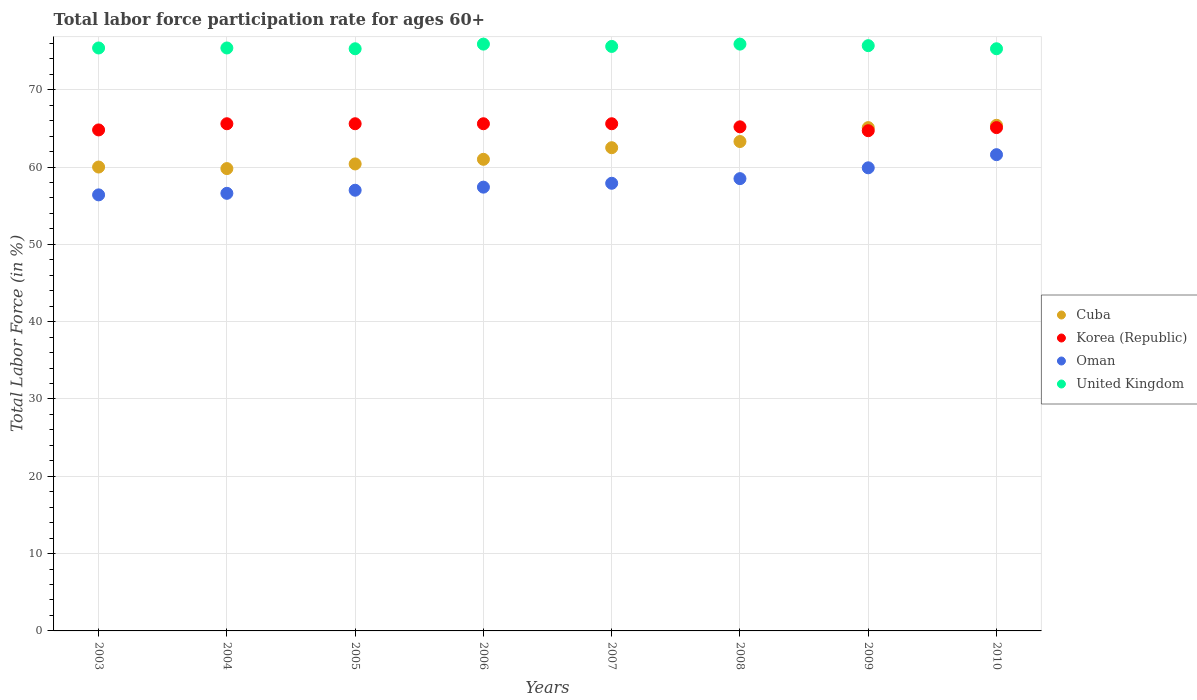Across all years, what is the maximum labor force participation rate in Korea (Republic)?
Make the answer very short. 65.6. Across all years, what is the minimum labor force participation rate in United Kingdom?
Your response must be concise. 75.3. In which year was the labor force participation rate in Oman maximum?
Provide a succinct answer. 2010. In which year was the labor force participation rate in Korea (Republic) minimum?
Ensure brevity in your answer.  2009. What is the total labor force participation rate in Korea (Republic) in the graph?
Your answer should be compact. 522.2. What is the difference between the labor force participation rate in Oman in 2006 and that in 2010?
Give a very brief answer. -4.2. What is the difference between the labor force participation rate in United Kingdom in 2006 and the labor force participation rate in Oman in 2009?
Give a very brief answer. 16. What is the average labor force participation rate in Oman per year?
Offer a very short reply. 58.16. In the year 2005, what is the difference between the labor force participation rate in Oman and labor force participation rate in Korea (Republic)?
Offer a very short reply. -8.6. What is the ratio of the labor force participation rate in Oman in 2003 to that in 2008?
Offer a terse response. 0.96. Is the labor force participation rate in United Kingdom in 2003 less than that in 2010?
Ensure brevity in your answer.  No. What is the difference between the highest and the second highest labor force participation rate in Cuba?
Your answer should be very brief. 0.3. What is the difference between the highest and the lowest labor force participation rate in Oman?
Your answer should be very brief. 5.2. In how many years, is the labor force participation rate in Korea (Republic) greater than the average labor force participation rate in Korea (Republic) taken over all years?
Give a very brief answer. 4. Is the sum of the labor force participation rate in United Kingdom in 2007 and 2009 greater than the maximum labor force participation rate in Cuba across all years?
Provide a succinct answer. Yes. Is the labor force participation rate in United Kingdom strictly less than the labor force participation rate in Oman over the years?
Your answer should be very brief. No. What is the difference between two consecutive major ticks on the Y-axis?
Your response must be concise. 10. Are the values on the major ticks of Y-axis written in scientific E-notation?
Give a very brief answer. No. Does the graph contain any zero values?
Your answer should be compact. No. Does the graph contain grids?
Provide a succinct answer. Yes. How many legend labels are there?
Your answer should be very brief. 4. How are the legend labels stacked?
Provide a succinct answer. Vertical. What is the title of the graph?
Your answer should be very brief. Total labor force participation rate for ages 60+. What is the label or title of the X-axis?
Provide a succinct answer. Years. What is the label or title of the Y-axis?
Offer a terse response. Total Labor Force (in %). What is the Total Labor Force (in %) in Korea (Republic) in 2003?
Offer a very short reply. 64.8. What is the Total Labor Force (in %) in Oman in 2003?
Give a very brief answer. 56.4. What is the Total Labor Force (in %) in United Kingdom in 2003?
Ensure brevity in your answer.  75.4. What is the Total Labor Force (in %) of Cuba in 2004?
Make the answer very short. 59.8. What is the Total Labor Force (in %) of Korea (Republic) in 2004?
Offer a terse response. 65.6. What is the Total Labor Force (in %) in Oman in 2004?
Make the answer very short. 56.6. What is the Total Labor Force (in %) of United Kingdom in 2004?
Give a very brief answer. 75.4. What is the Total Labor Force (in %) of Cuba in 2005?
Your answer should be very brief. 60.4. What is the Total Labor Force (in %) of Korea (Republic) in 2005?
Your answer should be compact. 65.6. What is the Total Labor Force (in %) of United Kingdom in 2005?
Offer a terse response. 75.3. What is the Total Labor Force (in %) of Cuba in 2006?
Provide a succinct answer. 61. What is the Total Labor Force (in %) of Korea (Republic) in 2006?
Provide a short and direct response. 65.6. What is the Total Labor Force (in %) of Oman in 2006?
Ensure brevity in your answer.  57.4. What is the Total Labor Force (in %) in United Kingdom in 2006?
Provide a short and direct response. 75.9. What is the Total Labor Force (in %) in Cuba in 2007?
Provide a succinct answer. 62.5. What is the Total Labor Force (in %) of Korea (Republic) in 2007?
Your answer should be very brief. 65.6. What is the Total Labor Force (in %) of Oman in 2007?
Your response must be concise. 57.9. What is the Total Labor Force (in %) of United Kingdom in 2007?
Offer a very short reply. 75.6. What is the Total Labor Force (in %) of Cuba in 2008?
Offer a terse response. 63.3. What is the Total Labor Force (in %) of Korea (Republic) in 2008?
Make the answer very short. 65.2. What is the Total Labor Force (in %) in Oman in 2008?
Provide a succinct answer. 58.5. What is the Total Labor Force (in %) of United Kingdom in 2008?
Your answer should be compact. 75.9. What is the Total Labor Force (in %) of Cuba in 2009?
Provide a short and direct response. 65.1. What is the Total Labor Force (in %) in Korea (Republic) in 2009?
Offer a terse response. 64.7. What is the Total Labor Force (in %) in Oman in 2009?
Your answer should be compact. 59.9. What is the Total Labor Force (in %) in United Kingdom in 2009?
Your answer should be very brief. 75.7. What is the Total Labor Force (in %) in Cuba in 2010?
Offer a very short reply. 65.4. What is the Total Labor Force (in %) in Korea (Republic) in 2010?
Make the answer very short. 65.1. What is the Total Labor Force (in %) of Oman in 2010?
Make the answer very short. 61.6. What is the Total Labor Force (in %) of United Kingdom in 2010?
Provide a succinct answer. 75.3. Across all years, what is the maximum Total Labor Force (in %) in Cuba?
Give a very brief answer. 65.4. Across all years, what is the maximum Total Labor Force (in %) of Korea (Republic)?
Your answer should be compact. 65.6. Across all years, what is the maximum Total Labor Force (in %) of Oman?
Your answer should be very brief. 61.6. Across all years, what is the maximum Total Labor Force (in %) of United Kingdom?
Give a very brief answer. 75.9. Across all years, what is the minimum Total Labor Force (in %) in Cuba?
Make the answer very short. 59.8. Across all years, what is the minimum Total Labor Force (in %) of Korea (Republic)?
Offer a terse response. 64.7. Across all years, what is the minimum Total Labor Force (in %) of Oman?
Your answer should be compact. 56.4. Across all years, what is the minimum Total Labor Force (in %) in United Kingdom?
Offer a very short reply. 75.3. What is the total Total Labor Force (in %) in Cuba in the graph?
Offer a very short reply. 497.5. What is the total Total Labor Force (in %) of Korea (Republic) in the graph?
Provide a short and direct response. 522.2. What is the total Total Labor Force (in %) in Oman in the graph?
Your answer should be very brief. 465.3. What is the total Total Labor Force (in %) of United Kingdom in the graph?
Give a very brief answer. 604.5. What is the difference between the Total Labor Force (in %) of Korea (Republic) in 2003 and that in 2004?
Provide a succinct answer. -0.8. What is the difference between the Total Labor Force (in %) of Oman in 2003 and that in 2004?
Keep it short and to the point. -0.2. What is the difference between the Total Labor Force (in %) of United Kingdom in 2003 and that in 2004?
Offer a very short reply. 0. What is the difference between the Total Labor Force (in %) in United Kingdom in 2003 and that in 2005?
Ensure brevity in your answer.  0.1. What is the difference between the Total Labor Force (in %) of Cuba in 2003 and that in 2006?
Give a very brief answer. -1. What is the difference between the Total Labor Force (in %) in Cuba in 2003 and that in 2008?
Ensure brevity in your answer.  -3.3. What is the difference between the Total Labor Force (in %) of Korea (Republic) in 2003 and that in 2008?
Provide a short and direct response. -0.4. What is the difference between the Total Labor Force (in %) in Cuba in 2003 and that in 2009?
Give a very brief answer. -5.1. What is the difference between the Total Labor Force (in %) in Oman in 2003 and that in 2009?
Ensure brevity in your answer.  -3.5. What is the difference between the Total Labor Force (in %) of Cuba in 2003 and that in 2010?
Your response must be concise. -5.4. What is the difference between the Total Labor Force (in %) in Korea (Republic) in 2003 and that in 2010?
Offer a very short reply. -0.3. What is the difference between the Total Labor Force (in %) in Oman in 2003 and that in 2010?
Ensure brevity in your answer.  -5.2. What is the difference between the Total Labor Force (in %) in Korea (Republic) in 2004 and that in 2005?
Make the answer very short. 0. What is the difference between the Total Labor Force (in %) of United Kingdom in 2004 and that in 2005?
Give a very brief answer. 0.1. What is the difference between the Total Labor Force (in %) in Cuba in 2004 and that in 2006?
Your response must be concise. -1.2. What is the difference between the Total Labor Force (in %) of Korea (Republic) in 2004 and that in 2006?
Provide a short and direct response. 0. What is the difference between the Total Labor Force (in %) of Oman in 2004 and that in 2006?
Offer a very short reply. -0.8. What is the difference between the Total Labor Force (in %) of Oman in 2004 and that in 2007?
Offer a very short reply. -1.3. What is the difference between the Total Labor Force (in %) of United Kingdom in 2004 and that in 2007?
Give a very brief answer. -0.2. What is the difference between the Total Labor Force (in %) of Cuba in 2004 and that in 2008?
Your answer should be very brief. -3.5. What is the difference between the Total Labor Force (in %) in United Kingdom in 2004 and that in 2008?
Keep it short and to the point. -0.5. What is the difference between the Total Labor Force (in %) in Korea (Republic) in 2004 and that in 2009?
Your answer should be very brief. 0.9. What is the difference between the Total Labor Force (in %) of Oman in 2004 and that in 2009?
Your answer should be very brief. -3.3. What is the difference between the Total Labor Force (in %) in United Kingdom in 2004 and that in 2009?
Give a very brief answer. -0.3. What is the difference between the Total Labor Force (in %) of Cuba in 2004 and that in 2010?
Give a very brief answer. -5.6. What is the difference between the Total Labor Force (in %) of Oman in 2005 and that in 2006?
Ensure brevity in your answer.  -0.4. What is the difference between the Total Labor Force (in %) of United Kingdom in 2005 and that in 2007?
Make the answer very short. -0.3. What is the difference between the Total Labor Force (in %) of Cuba in 2005 and that in 2008?
Ensure brevity in your answer.  -2.9. What is the difference between the Total Labor Force (in %) in Oman in 2005 and that in 2008?
Provide a short and direct response. -1.5. What is the difference between the Total Labor Force (in %) of Cuba in 2005 and that in 2009?
Make the answer very short. -4.7. What is the difference between the Total Labor Force (in %) of Oman in 2005 and that in 2009?
Offer a terse response. -2.9. What is the difference between the Total Labor Force (in %) of United Kingdom in 2005 and that in 2009?
Provide a short and direct response. -0.4. What is the difference between the Total Labor Force (in %) of Cuba in 2005 and that in 2010?
Your answer should be compact. -5. What is the difference between the Total Labor Force (in %) in Oman in 2005 and that in 2010?
Your answer should be very brief. -4.6. What is the difference between the Total Labor Force (in %) in Cuba in 2006 and that in 2007?
Your response must be concise. -1.5. What is the difference between the Total Labor Force (in %) of Korea (Republic) in 2006 and that in 2007?
Make the answer very short. 0. What is the difference between the Total Labor Force (in %) in Oman in 2006 and that in 2007?
Your answer should be very brief. -0.5. What is the difference between the Total Labor Force (in %) in Cuba in 2006 and that in 2008?
Your response must be concise. -2.3. What is the difference between the Total Labor Force (in %) in Korea (Republic) in 2006 and that in 2008?
Provide a succinct answer. 0.4. What is the difference between the Total Labor Force (in %) in Cuba in 2006 and that in 2009?
Make the answer very short. -4.1. What is the difference between the Total Labor Force (in %) of Korea (Republic) in 2006 and that in 2009?
Give a very brief answer. 0.9. What is the difference between the Total Labor Force (in %) of Cuba in 2007 and that in 2008?
Provide a succinct answer. -0.8. What is the difference between the Total Labor Force (in %) of United Kingdom in 2007 and that in 2008?
Give a very brief answer. -0.3. What is the difference between the Total Labor Force (in %) of Oman in 2007 and that in 2009?
Keep it short and to the point. -2. What is the difference between the Total Labor Force (in %) in United Kingdom in 2007 and that in 2009?
Ensure brevity in your answer.  -0.1. What is the difference between the Total Labor Force (in %) of Cuba in 2007 and that in 2010?
Keep it short and to the point. -2.9. What is the difference between the Total Labor Force (in %) in Korea (Republic) in 2007 and that in 2010?
Offer a very short reply. 0.5. What is the difference between the Total Labor Force (in %) of Oman in 2007 and that in 2010?
Ensure brevity in your answer.  -3.7. What is the difference between the Total Labor Force (in %) of United Kingdom in 2008 and that in 2009?
Keep it short and to the point. 0.2. What is the difference between the Total Labor Force (in %) in Korea (Republic) in 2008 and that in 2010?
Your answer should be very brief. 0.1. What is the difference between the Total Labor Force (in %) in Oman in 2008 and that in 2010?
Provide a short and direct response. -3.1. What is the difference between the Total Labor Force (in %) in Cuba in 2009 and that in 2010?
Your answer should be compact. -0.3. What is the difference between the Total Labor Force (in %) in Oman in 2009 and that in 2010?
Your answer should be very brief. -1.7. What is the difference between the Total Labor Force (in %) in Cuba in 2003 and the Total Labor Force (in %) in United Kingdom in 2004?
Your answer should be compact. -15.4. What is the difference between the Total Labor Force (in %) of Oman in 2003 and the Total Labor Force (in %) of United Kingdom in 2004?
Your response must be concise. -19. What is the difference between the Total Labor Force (in %) of Cuba in 2003 and the Total Labor Force (in %) of Oman in 2005?
Ensure brevity in your answer.  3. What is the difference between the Total Labor Force (in %) in Cuba in 2003 and the Total Labor Force (in %) in United Kingdom in 2005?
Your answer should be very brief. -15.3. What is the difference between the Total Labor Force (in %) in Oman in 2003 and the Total Labor Force (in %) in United Kingdom in 2005?
Give a very brief answer. -18.9. What is the difference between the Total Labor Force (in %) in Cuba in 2003 and the Total Labor Force (in %) in Korea (Republic) in 2006?
Give a very brief answer. -5.6. What is the difference between the Total Labor Force (in %) in Cuba in 2003 and the Total Labor Force (in %) in Oman in 2006?
Your answer should be very brief. 2.6. What is the difference between the Total Labor Force (in %) of Cuba in 2003 and the Total Labor Force (in %) of United Kingdom in 2006?
Provide a succinct answer. -15.9. What is the difference between the Total Labor Force (in %) in Korea (Republic) in 2003 and the Total Labor Force (in %) in United Kingdom in 2006?
Make the answer very short. -11.1. What is the difference between the Total Labor Force (in %) in Oman in 2003 and the Total Labor Force (in %) in United Kingdom in 2006?
Your response must be concise. -19.5. What is the difference between the Total Labor Force (in %) in Cuba in 2003 and the Total Labor Force (in %) in Korea (Republic) in 2007?
Offer a terse response. -5.6. What is the difference between the Total Labor Force (in %) in Cuba in 2003 and the Total Labor Force (in %) in United Kingdom in 2007?
Provide a short and direct response. -15.6. What is the difference between the Total Labor Force (in %) of Korea (Republic) in 2003 and the Total Labor Force (in %) of Oman in 2007?
Your answer should be compact. 6.9. What is the difference between the Total Labor Force (in %) in Oman in 2003 and the Total Labor Force (in %) in United Kingdom in 2007?
Offer a terse response. -19.2. What is the difference between the Total Labor Force (in %) in Cuba in 2003 and the Total Labor Force (in %) in Korea (Republic) in 2008?
Your response must be concise. -5.2. What is the difference between the Total Labor Force (in %) in Cuba in 2003 and the Total Labor Force (in %) in Oman in 2008?
Provide a short and direct response. 1.5. What is the difference between the Total Labor Force (in %) in Cuba in 2003 and the Total Labor Force (in %) in United Kingdom in 2008?
Make the answer very short. -15.9. What is the difference between the Total Labor Force (in %) in Korea (Republic) in 2003 and the Total Labor Force (in %) in Oman in 2008?
Offer a terse response. 6.3. What is the difference between the Total Labor Force (in %) of Oman in 2003 and the Total Labor Force (in %) of United Kingdom in 2008?
Offer a very short reply. -19.5. What is the difference between the Total Labor Force (in %) in Cuba in 2003 and the Total Labor Force (in %) in Oman in 2009?
Ensure brevity in your answer.  0.1. What is the difference between the Total Labor Force (in %) in Cuba in 2003 and the Total Labor Force (in %) in United Kingdom in 2009?
Offer a very short reply. -15.7. What is the difference between the Total Labor Force (in %) in Korea (Republic) in 2003 and the Total Labor Force (in %) in Oman in 2009?
Your answer should be compact. 4.9. What is the difference between the Total Labor Force (in %) in Korea (Republic) in 2003 and the Total Labor Force (in %) in United Kingdom in 2009?
Give a very brief answer. -10.9. What is the difference between the Total Labor Force (in %) of Oman in 2003 and the Total Labor Force (in %) of United Kingdom in 2009?
Make the answer very short. -19.3. What is the difference between the Total Labor Force (in %) in Cuba in 2003 and the Total Labor Force (in %) in United Kingdom in 2010?
Offer a terse response. -15.3. What is the difference between the Total Labor Force (in %) of Korea (Republic) in 2003 and the Total Labor Force (in %) of Oman in 2010?
Your response must be concise. 3.2. What is the difference between the Total Labor Force (in %) of Korea (Republic) in 2003 and the Total Labor Force (in %) of United Kingdom in 2010?
Offer a terse response. -10.5. What is the difference between the Total Labor Force (in %) of Oman in 2003 and the Total Labor Force (in %) of United Kingdom in 2010?
Give a very brief answer. -18.9. What is the difference between the Total Labor Force (in %) of Cuba in 2004 and the Total Labor Force (in %) of Korea (Republic) in 2005?
Ensure brevity in your answer.  -5.8. What is the difference between the Total Labor Force (in %) of Cuba in 2004 and the Total Labor Force (in %) of Oman in 2005?
Make the answer very short. 2.8. What is the difference between the Total Labor Force (in %) in Cuba in 2004 and the Total Labor Force (in %) in United Kingdom in 2005?
Provide a succinct answer. -15.5. What is the difference between the Total Labor Force (in %) in Korea (Republic) in 2004 and the Total Labor Force (in %) in Oman in 2005?
Make the answer very short. 8.6. What is the difference between the Total Labor Force (in %) in Oman in 2004 and the Total Labor Force (in %) in United Kingdom in 2005?
Keep it short and to the point. -18.7. What is the difference between the Total Labor Force (in %) in Cuba in 2004 and the Total Labor Force (in %) in United Kingdom in 2006?
Make the answer very short. -16.1. What is the difference between the Total Labor Force (in %) in Oman in 2004 and the Total Labor Force (in %) in United Kingdom in 2006?
Your answer should be compact. -19.3. What is the difference between the Total Labor Force (in %) in Cuba in 2004 and the Total Labor Force (in %) in Korea (Republic) in 2007?
Give a very brief answer. -5.8. What is the difference between the Total Labor Force (in %) in Cuba in 2004 and the Total Labor Force (in %) in Oman in 2007?
Your answer should be very brief. 1.9. What is the difference between the Total Labor Force (in %) in Cuba in 2004 and the Total Labor Force (in %) in United Kingdom in 2007?
Your answer should be very brief. -15.8. What is the difference between the Total Labor Force (in %) in Cuba in 2004 and the Total Labor Force (in %) in Oman in 2008?
Ensure brevity in your answer.  1.3. What is the difference between the Total Labor Force (in %) of Cuba in 2004 and the Total Labor Force (in %) of United Kingdom in 2008?
Give a very brief answer. -16.1. What is the difference between the Total Labor Force (in %) of Korea (Republic) in 2004 and the Total Labor Force (in %) of Oman in 2008?
Offer a very short reply. 7.1. What is the difference between the Total Labor Force (in %) of Oman in 2004 and the Total Labor Force (in %) of United Kingdom in 2008?
Your answer should be compact. -19.3. What is the difference between the Total Labor Force (in %) of Cuba in 2004 and the Total Labor Force (in %) of Korea (Republic) in 2009?
Keep it short and to the point. -4.9. What is the difference between the Total Labor Force (in %) in Cuba in 2004 and the Total Labor Force (in %) in United Kingdom in 2009?
Make the answer very short. -15.9. What is the difference between the Total Labor Force (in %) of Korea (Republic) in 2004 and the Total Labor Force (in %) of Oman in 2009?
Your answer should be compact. 5.7. What is the difference between the Total Labor Force (in %) in Korea (Republic) in 2004 and the Total Labor Force (in %) in United Kingdom in 2009?
Keep it short and to the point. -10.1. What is the difference between the Total Labor Force (in %) of Oman in 2004 and the Total Labor Force (in %) of United Kingdom in 2009?
Ensure brevity in your answer.  -19.1. What is the difference between the Total Labor Force (in %) in Cuba in 2004 and the Total Labor Force (in %) in Korea (Republic) in 2010?
Keep it short and to the point. -5.3. What is the difference between the Total Labor Force (in %) in Cuba in 2004 and the Total Labor Force (in %) in Oman in 2010?
Give a very brief answer. -1.8. What is the difference between the Total Labor Force (in %) in Cuba in 2004 and the Total Labor Force (in %) in United Kingdom in 2010?
Provide a succinct answer. -15.5. What is the difference between the Total Labor Force (in %) in Korea (Republic) in 2004 and the Total Labor Force (in %) in Oman in 2010?
Ensure brevity in your answer.  4. What is the difference between the Total Labor Force (in %) of Oman in 2004 and the Total Labor Force (in %) of United Kingdom in 2010?
Keep it short and to the point. -18.7. What is the difference between the Total Labor Force (in %) of Cuba in 2005 and the Total Labor Force (in %) of United Kingdom in 2006?
Ensure brevity in your answer.  -15.5. What is the difference between the Total Labor Force (in %) in Korea (Republic) in 2005 and the Total Labor Force (in %) in United Kingdom in 2006?
Keep it short and to the point. -10.3. What is the difference between the Total Labor Force (in %) of Oman in 2005 and the Total Labor Force (in %) of United Kingdom in 2006?
Your response must be concise. -18.9. What is the difference between the Total Labor Force (in %) in Cuba in 2005 and the Total Labor Force (in %) in Oman in 2007?
Keep it short and to the point. 2.5. What is the difference between the Total Labor Force (in %) in Cuba in 2005 and the Total Labor Force (in %) in United Kingdom in 2007?
Make the answer very short. -15.2. What is the difference between the Total Labor Force (in %) of Korea (Republic) in 2005 and the Total Labor Force (in %) of United Kingdom in 2007?
Your response must be concise. -10. What is the difference between the Total Labor Force (in %) of Oman in 2005 and the Total Labor Force (in %) of United Kingdom in 2007?
Offer a very short reply. -18.6. What is the difference between the Total Labor Force (in %) in Cuba in 2005 and the Total Labor Force (in %) in Korea (Republic) in 2008?
Keep it short and to the point. -4.8. What is the difference between the Total Labor Force (in %) of Cuba in 2005 and the Total Labor Force (in %) of United Kingdom in 2008?
Offer a terse response. -15.5. What is the difference between the Total Labor Force (in %) of Korea (Republic) in 2005 and the Total Labor Force (in %) of Oman in 2008?
Provide a succinct answer. 7.1. What is the difference between the Total Labor Force (in %) in Oman in 2005 and the Total Labor Force (in %) in United Kingdom in 2008?
Your response must be concise. -18.9. What is the difference between the Total Labor Force (in %) of Cuba in 2005 and the Total Labor Force (in %) of Oman in 2009?
Ensure brevity in your answer.  0.5. What is the difference between the Total Labor Force (in %) in Cuba in 2005 and the Total Labor Force (in %) in United Kingdom in 2009?
Your response must be concise. -15.3. What is the difference between the Total Labor Force (in %) of Korea (Republic) in 2005 and the Total Labor Force (in %) of Oman in 2009?
Provide a succinct answer. 5.7. What is the difference between the Total Labor Force (in %) of Oman in 2005 and the Total Labor Force (in %) of United Kingdom in 2009?
Offer a terse response. -18.7. What is the difference between the Total Labor Force (in %) in Cuba in 2005 and the Total Labor Force (in %) in Oman in 2010?
Offer a terse response. -1.2. What is the difference between the Total Labor Force (in %) in Cuba in 2005 and the Total Labor Force (in %) in United Kingdom in 2010?
Offer a very short reply. -14.9. What is the difference between the Total Labor Force (in %) of Korea (Republic) in 2005 and the Total Labor Force (in %) of United Kingdom in 2010?
Provide a succinct answer. -9.7. What is the difference between the Total Labor Force (in %) of Oman in 2005 and the Total Labor Force (in %) of United Kingdom in 2010?
Ensure brevity in your answer.  -18.3. What is the difference between the Total Labor Force (in %) of Cuba in 2006 and the Total Labor Force (in %) of United Kingdom in 2007?
Give a very brief answer. -14.6. What is the difference between the Total Labor Force (in %) of Korea (Republic) in 2006 and the Total Labor Force (in %) of Oman in 2007?
Keep it short and to the point. 7.7. What is the difference between the Total Labor Force (in %) in Korea (Republic) in 2006 and the Total Labor Force (in %) in United Kingdom in 2007?
Give a very brief answer. -10. What is the difference between the Total Labor Force (in %) of Oman in 2006 and the Total Labor Force (in %) of United Kingdom in 2007?
Your answer should be very brief. -18.2. What is the difference between the Total Labor Force (in %) of Cuba in 2006 and the Total Labor Force (in %) of United Kingdom in 2008?
Your answer should be very brief. -14.9. What is the difference between the Total Labor Force (in %) in Oman in 2006 and the Total Labor Force (in %) in United Kingdom in 2008?
Offer a terse response. -18.5. What is the difference between the Total Labor Force (in %) of Cuba in 2006 and the Total Labor Force (in %) of Korea (Republic) in 2009?
Your response must be concise. -3.7. What is the difference between the Total Labor Force (in %) of Cuba in 2006 and the Total Labor Force (in %) of United Kingdom in 2009?
Ensure brevity in your answer.  -14.7. What is the difference between the Total Labor Force (in %) in Korea (Republic) in 2006 and the Total Labor Force (in %) in Oman in 2009?
Ensure brevity in your answer.  5.7. What is the difference between the Total Labor Force (in %) of Oman in 2006 and the Total Labor Force (in %) of United Kingdom in 2009?
Ensure brevity in your answer.  -18.3. What is the difference between the Total Labor Force (in %) of Cuba in 2006 and the Total Labor Force (in %) of Korea (Republic) in 2010?
Offer a very short reply. -4.1. What is the difference between the Total Labor Force (in %) in Cuba in 2006 and the Total Labor Force (in %) in United Kingdom in 2010?
Provide a succinct answer. -14.3. What is the difference between the Total Labor Force (in %) in Oman in 2006 and the Total Labor Force (in %) in United Kingdom in 2010?
Offer a terse response. -17.9. What is the difference between the Total Labor Force (in %) of Cuba in 2007 and the Total Labor Force (in %) of Oman in 2008?
Give a very brief answer. 4. What is the difference between the Total Labor Force (in %) of Cuba in 2007 and the Total Labor Force (in %) of United Kingdom in 2008?
Give a very brief answer. -13.4. What is the difference between the Total Labor Force (in %) of Korea (Republic) in 2007 and the Total Labor Force (in %) of United Kingdom in 2008?
Provide a short and direct response. -10.3. What is the difference between the Total Labor Force (in %) of Cuba in 2007 and the Total Labor Force (in %) of United Kingdom in 2009?
Provide a succinct answer. -13.2. What is the difference between the Total Labor Force (in %) of Korea (Republic) in 2007 and the Total Labor Force (in %) of United Kingdom in 2009?
Make the answer very short. -10.1. What is the difference between the Total Labor Force (in %) of Oman in 2007 and the Total Labor Force (in %) of United Kingdom in 2009?
Give a very brief answer. -17.8. What is the difference between the Total Labor Force (in %) in Cuba in 2007 and the Total Labor Force (in %) in Korea (Republic) in 2010?
Your answer should be compact. -2.6. What is the difference between the Total Labor Force (in %) in Cuba in 2007 and the Total Labor Force (in %) in United Kingdom in 2010?
Make the answer very short. -12.8. What is the difference between the Total Labor Force (in %) of Korea (Republic) in 2007 and the Total Labor Force (in %) of United Kingdom in 2010?
Offer a terse response. -9.7. What is the difference between the Total Labor Force (in %) of Oman in 2007 and the Total Labor Force (in %) of United Kingdom in 2010?
Provide a short and direct response. -17.4. What is the difference between the Total Labor Force (in %) in Cuba in 2008 and the Total Labor Force (in %) in Oman in 2009?
Ensure brevity in your answer.  3.4. What is the difference between the Total Labor Force (in %) of Oman in 2008 and the Total Labor Force (in %) of United Kingdom in 2009?
Provide a short and direct response. -17.2. What is the difference between the Total Labor Force (in %) of Oman in 2008 and the Total Labor Force (in %) of United Kingdom in 2010?
Make the answer very short. -16.8. What is the difference between the Total Labor Force (in %) of Cuba in 2009 and the Total Labor Force (in %) of Korea (Republic) in 2010?
Make the answer very short. 0. What is the difference between the Total Labor Force (in %) in Oman in 2009 and the Total Labor Force (in %) in United Kingdom in 2010?
Keep it short and to the point. -15.4. What is the average Total Labor Force (in %) of Cuba per year?
Provide a succinct answer. 62.19. What is the average Total Labor Force (in %) of Korea (Republic) per year?
Offer a very short reply. 65.28. What is the average Total Labor Force (in %) in Oman per year?
Provide a short and direct response. 58.16. What is the average Total Labor Force (in %) in United Kingdom per year?
Make the answer very short. 75.56. In the year 2003, what is the difference between the Total Labor Force (in %) of Cuba and Total Labor Force (in %) of Oman?
Make the answer very short. 3.6. In the year 2003, what is the difference between the Total Labor Force (in %) in Cuba and Total Labor Force (in %) in United Kingdom?
Offer a terse response. -15.4. In the year 2003, what is the difference between the Total Labor Force (in %) in Korea (Republic) and Total Labor Force (in %) in Oman?
Make the answer very short. 8.4. In the year 2003, what is the difference between the Total Labor Force (in %) of Oman and Total Labor Force (in %) of United Kingdom?
Make the answer very short. -19. In the year 2004, what is the difference between the Total Labor Force (in %) of Cuba and Total Labor Force (in %) of Korea (Republic)?
Make the answer very short. -5.8. In the year 2004, what is the difference between the Total Labor Force (in %) of Cuba and Total Labor Force (in %) of United Kingdom?
Your response must be concise. -15.6. In the year 2004, what is the difference between the Total Labor Force (in %) of Korea (Republic) and Total Labor Force (in %) of Oman?
Offer a very short reply. 9. In the year 2004, what is the difference between the Total Labor Force (in %) of Oman and Total Labor Force (in %) of United Kingdom?
Provide a succinct answer. -18.8. In the year 2005, what is the difference between the Total Labor Force (in %) of Cuba and Total Labor Force (in %) of Korea (Republic)?
Your answer should be very brief. -5.2. In the year 2005, what is the difference between the Total Labor Force (in %) in Cuba and Total Labor Force (in %) in United Kingdom?
Offer a terse response. -14.9. In the year 2005, what is the difference between the Total Labor Force (in %) of Korea (Republic) and Total Labor Force (in %) of United Kingdom?
Your answer should be compact. -9.7. In the year 2005, what is the difference between the Total Labor Force (in %) of Oman and Total Labor Force (in %) of United Kingdom?
Keep it short and to the point. -18.3. In the year 2006, what is the difference between the Total Labor Force (in %) in Cuba and Total Labor Force (in %) in Korea (Republic)?
Provide a short and direct response. -4.6. In the year 2006, what is the difference between the Total Labor Force (in %) in Cuba and Total Labor Force (in %) in Oman?
Your answer should be very brief. 3.6. In the year 2006, what is the difference between the Total Labor Force (in %) in Cuba and Total Labor Force (in %) in United Kingdom?
Keep it short and to the point. -14.9. In the year 2006, what is the difference between the Total Labor Force (in %) of Oman and Total Labor Force (in %) of United Kingdom?
Give a very brief answer. -18.5. In the year 2007, what is the difference between the Total Labor Force (in %) of Cuba and Total Labor Force (in %) of Oman?
Provide a short and direct response. 4.6. In the year 2007, what is the difference between the Total Labor Force (in %) of Cuba and Total Labor Force (in %) of United Kingdom?
Your response must be concise. -13.1. In the year 2007, what is the difference between the Total Labor Force (in %) of Oman and Total Labor Force (in %) of United Kingdom?
Make the answer very short. -17.7. In the year 2008, what is the difference between the Total Labor Force (in %) of Cuba and Total Labor Force (in %) of Korea (Republic)?
Offer a very short reply. -1.9. In the year 2008, what is the difference between the Total Labor Force (in %) in Cuba and Total Labor Force (in %) in Oman?
Make the answer very short. 4.8. In the year 2008, what is the difference between the Total Labor Force (in %) of Cuba and Total Labor Force (in %) of United Kingdom?
Your answer should be compact. -12.6. In the year 2008, what is the difference between the Total Labor Force (in %) in Korea (Republic) and Total Labor Force (in %) in United Kingdom?
Offer a very short reply. -10.7. In the year 2008, what is the difference between the Total Labor Force (in %) in Oman and Total Labor Force (in %) in United Kingdom?
Your answer should be compact. -17.4. In the year 2009, what is the difference between the Total Labor Force (in %) of Cuba and Total Labor Force (in %) of Korea (Republic)?
Your response must be concise. 0.4. In the year 2009, what is the difference between the Total Labor Force (in %) in Cuba and Total Labor Force (in %) in Oman?
Your answer should be compact. 5.2. In the year 2009, what is the difference between the Total Labor Force (in %) of Cuba and Total Labor Force (in %) of United Kingdom?
Give a very brief answer. -10.6. In the year 2009, what is the difference between the Total Labor Force (in %) of Korea (Republic) and Total Labor Force (in %) of Oman?
Give a very brief answer. 4.8. In the year 2009, what is the difference between the Total Labor Force (in %) in Oman and Total Labor Force (in %) in United Kingdom?
Offer a very short reply. -15.8. In the year 2010, what is the difference between the Total Labor Force (in %) in Cuba and Total Labor Force (in %) in Korea (Republic)?
Make the answer very short. 0.3. In the year 2010, what is the difference between the Total Labor Force (in %) in Cuba and Total Labor Force (in %) in Oman?
Provide a succinct answer. 3.8. In the year 2010, what is the difference between the Total Labor Force (in %) in Cuba and Total Labor Force (in %) in United Kingdom?
Provide a short and direct response. -9.9. In the year 2010, what is the difference between the Total Labor Force (in %) of Oman and Total Labor Force (in %) of United Kingdom?
Give a very brief answer. -13.7. What is the ratio of the Total Labor Force (in %) of Cuba in 2003 to that in 2004?
Your answer should be compact. 1. What is the ratio of the Total Labor Force (in %) of Oman in 2003 to that in 2004?
Provide a succinct answer. 1. What is the ratio of the Total Labor Force (in %) of Cuba in 2003 to that in 2005?
Ensure brevity in your answer.  0.99. What is the ratio of the Total Labor Force (in %) of United Kingdom in 2003 to that in 2005?
Ensure brevity in your answer.  1. What is the ratio of the Total Labor Force (in %) of Cuba in 2003 to that in 2006?
Your answer should be very brief. 0.98. What is the ratio of the Total Labor Force (in %) of Korea (Republic) in 2003 to that in 2006?
Ensure brevity in your answer.  0.99. What is the ratio of the Total Labor Force (in %) in Oman in 2003 to that in 2006?
Provide a short and direct response. 0.98. What is the ratio of the Total Labor Force (in %) in Oman in 2003 to that in 2007?
Your answer should be very brief. 0.97. What is the ratio of the Total Labor Force (in %) of United Kingdom in 2003 to that in 2007?
Your response must be concise. 1. What is the ratio of the Total Labor Force (in %) of Cuba in 2003 to that in 2008?
Your response must be concise. 0.95. What is the ratio of the Total Labor Force (in %) of Korea (Republic) in 2003 to that in 2008?
Provide a succinct answer. 0.99. What is the ratio of the Total Labor Force (in %) in Oman in 2003 to that in 2008?
Your answer should be very brief. 0.96. What is the ratio of the Total Labor Force (in %) in United Kingdom in 2003 to that in 2008?
Your answer should be very brief. 0.99. What is the ratio of the Total Labor Force (in %) in Cuba in 2003 to that in 2009?
Your response must be concise. 0.92. What is the ratio of the Total Labor Force (in %) in Korea (Republic) in 2003 to that in 2009?
Offer a very short reply. 1. What is the ratio of the Total Labor Force (in %) of Oman in 2003 to that in 2009?
Your answer should be compact. 0.94. What is the ratio of the Total Labor Force (in %) of Cuba in 2003 to that in 2010?
Your response must be concise. 0.92. What is the ratio of the Total Labor Force (in %) in Oman in 2003 to that in 2010?
Offer a very short reply. 0.92. What is the ratio of the Total Labor Force (in %) of United Kingdom in 2003 to that in 2010?
Keep it short and to the point. 1. What is the ratio of the Total Labor Force (in %) in Korea (Republic) in 2004 to that in 2005?
Keep it short and to the point. 1. What is the ratio of the Total Labor Force (in %) of Oman in 2004 to that in 2005?
Your answer should be very brief. 0.99. What is the ratio of the Total Labor Force (in %) of Cuba in 2004 to that in 2006?
Offer a very short reply. 0.98. What is the ratio of the Total Labor Force (in %) in Oman in 2004 to that in 2006?
Offer a very short reply. 0.99. What is the ratio of the Total Labor Force (in %) in Cuba in 2004 to that in 2007?
Make the answer very short. 0.96. What is the ratio of the Total Labor Force (in %) of Korea (Republic) in 2004 to that in 2007?
Offer a terse response. 1. What is the ratio of the Total Labor Force (in %) of Oman in 2004 to that in 2007?
Offer a terse response. 0.98. What is the ratio of the Total Labor Force (in %) of United Kingdom in 2004 to that in 2007?
Provide a succinct answer. 1. What is the ratio of the Total Labor Force (in %) of Cuba in 2004 to that in 2008?
Give a very brief answer. 0.94. What is the ratio of the Total Labor Force (in %) in Oman in 2004 to that in 2008?
Make the answer very short. 0.97. What is the ratio of the Total Labor Force (in %) of United Kingdom in 2004 to that in 2008?
Provide a succinct answer. 0.99. What is the ratio of the Total Labor Force (in %) in Cuba in 2004 to that in 2009?
Your answer should be very brief. 0.92. What is the ratio of the Total Labor Force (in %) in Korea (Republic) in 2004 to that in 2009?
Your answer should be compact. 1.01. What is the ratio of the Total Labor Force (in %) in Oman in 2004 to that in 2009?
Ensure brevity in your answer.  0.94. What is the ratio of the Total Labor Force (in %) of United Kingdom in 2004 to that in 2009?
Your answer should be very brief. 1. What is the ratio of the Total Labor Force (in %) of Cuba in 2004 to that in 2010?
Offer a very short reply. 0.91. What is the ratio of the Total Labor Force (in %) in Korea (Republic) in 2004 to that in 2010?
Offer a terse response. 1.01. What is the ratio of the Total Labor Force (in %) in Oman in 2004 to that in 2010?
Make the answer very short. 0.92. What is the ratio of the Total Labor Force (in %) of Cuba in 2005 to that in 2006?
Your response must be concise. 0.99. What is the ratio of the Total Labor Force (in %) in Korea (Republic) in 2005 to that in 2006?
Offer a terse response. 1. What is the ratio of the Total Labor Force (in %) in Oman in 2005 to that in 2006?
Your answer should be very brief. 0.99. What is the ratio of the Total Labor Force (in %) in Cuba in 2005 to that in 2007?
Give a very brief answer. 0.97. What is the ratio of the Total Labor Force (in %) in Oman in 2005 to that in 2007?
Provide a short and direct response. 0.98. What is the ratio of the Total Labor Force (in %) of Cuba in 2005 to that in 2008?
Offer a very short reply. 0.95. What is the ratio of the Total Labor Force (in %) in Korea (Republic) in 2005 to that in 2008?
Give a very brief answer. 1.01. What is the ratio of the Total Labor Force (in %) in Oman in 2005 to that in 2008?
Offer a very short reply. 0.97. What is the ratio of the Total Labor Force (in %) of Cuba in 2005 to that in 2009?
Provide a short and direct response. 0.93. What is the ratio of the Total Labor Force (in %) in Korea (Republic) in 2005 to that in 2009?
Offer a very short reply. 1.01. What is the ratio of the Total Labor Force (in %) in Oman in 2005 to that in 2009?
Your answer should be very brief. 0.95. What is the ratio of the Total Labor Force (in %) of Cuba in 2005 to that in 2010?
Your response must be concise. 0.92. What is the ratio of the Total Labor Force (in %) in Korea (Republic) in 2005 to that in 2010?
Offer a very short reply. 1.01. What is the ratio of the Total Labor Force (in %) of Oman in 2005 to that in 2010?
Make the answer very short. 0.93. What is the ratio of the Total Labor Force (in %) in Korea (Republic) in 2006 to that in 2007?
Ensure brevity in your answer.  1. What is the ratio of the Total Labor Force (in %) of Oman in 2006 to that in 2007?
Your response must be concise. 0.99. What is the ratio of the Total Labor Force (in %) in United Kingdom in 2006 to that in 2007?
Make the answer very short. 1. What is the ratio of the Total Labor Force (in %) of Cuba in 2006 to that in 2008?
Provide a short and direct response. 0.96. What is the ratio of the Total Labor Force (in %) of Oman in 2006 to that in 2008?
Your response must be concise. 0.98. What is the ratio of the Total Labor Force (in %) in United Kingdom in 2006 to that in 2008?
Make the answer very short. 1. What is the ratio of the Total Labor Force (in %) of Cuba in 2006 to that in 2009?
Offer a very short reply. 0.94. What is the ratio of the Total Labor Force (in %) of Korea (Republic) in 2006 to that in 2009?
Offer a very short reply. 1.01. What is the ratio of the Total Labor Force (in %) of Oman in 2006 to that in 2009?
Your answer should be compact. 0.96. What is the ratio of the Total Labor Force (in %) of Cuba in 2006 to that in 2010?
Your response must be concise. 0.93. What is the ratio of the Total Labor Force (in %) in Korea (Republic) in 2006 to that in 2010?
Provide a short and direct response. 1.01. What is the ratio of the Total Labor Force (in %) of Oman in 2006 to that in 2010?
Offer a terse response. 0.93. What is the ratio of the Total Labor Force (in %) in Cuba in 2007 to that in 2008?
Offer a terse response. 0.99. What is the ratio of the Total Labor Force (in %) of United Kingdom in 2007 to that in 2008?
Provide a succinct answer. 1. What is the ratio of the Total Labor Force (in %) in Cuba in 2007 to that in 2009?
Keep it short and to the point. 0.96. What is the ratio of the Total Labor Force (in %) of Korea (Republic) in 2007 to that in 2009?
Ensure brevity in your answer.  1.01. What is the ratio of the Total Labor Force (in %) in Oman in 2007 to that in 2009?
Give a very brief answer. 0.97. What is the ratio of the Total Labor Force (in %) in United Kingdom in 2007 to that in 2009?
Provide a short and direct response. 1. What is the ratio of the Total Labor Force (in %) of Cuba in 2007 to that in 2010?
Provide a succinct answer. 0.96. What is the ratio of the Total Labor Force (in %) of Korea (Republic) in 2007 to that in 2010?
Give a very brief answer. 1.01. What is the ratio of the Total Labor Force (in %) of Oman in 2007 to that in 2010?
Keep it short and to the point. 0.94. What is the ratio of the Total Labor Force (in %) of Cuba in 2008 to that in 2009?
Your response must be concise. 0.97. What is the ratio of the Total Labor Force (in %) of Korea (Republic) in 2008 to that in 2009?
Ensure brevity in your answer.  1.01. What is the ratio of the Total Labor Force (in %) of Oman in 2008 to that in 2009?
Provide a short and direct response. 0.98. What is the ratio of the Total Labor Force (in %) in United Kingdom in 2008 to that in 2009?
Provide a succinct answer. 1. What is the ratio of the Total Labor Force (in %) in Cuba in 2008 to that in 2010?
Offer a terse response. 0.97. What is the ratio of the Total Labor Force (in %) of Oman in 2008 to that in 2010?
Offer a very short reply. 0.95. What is the ratio of the Total Labor Force (in %) of Cuba in 2009 to that in 2010?
Your answer should be compact. 1. What is the ratio of the Total Labor Force (in %) of Oman in 2009 to that in 2010?
Offer a very short reply. 0.97. What is the ratio of the Total Labor Force (in %) in United Kingdom in 2009 to that in 2010?
Provide a succinct answer. 1.01. What is the difference between the highest and the second highest Total Labor Force (in %) in Cuba?
Your answer should be compact. 0.3. What is the difference between the highest and the second highest Total Labor Force (in %) in United Kingdom?
Make the answer very short. 0. What is the difference between the highest and the lowest Total Labor Force (in %) in United Kingdom?
Your answer should be very brief. 0.6. 